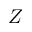Convert formula to latex. <formula><loc_0><loc_0><loc_500><loc_500>Z</formula> 